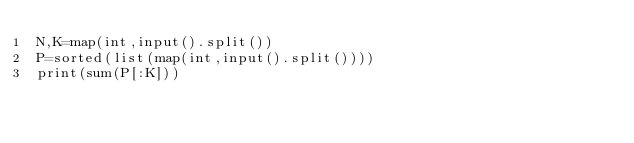<code> <loc_0><loc_0><loc_500><loc_500><_Python_>N,K=map(int,input().split())
P=sorted(list(map(int,input().split())))
print(sum(P[:K]))</code> 